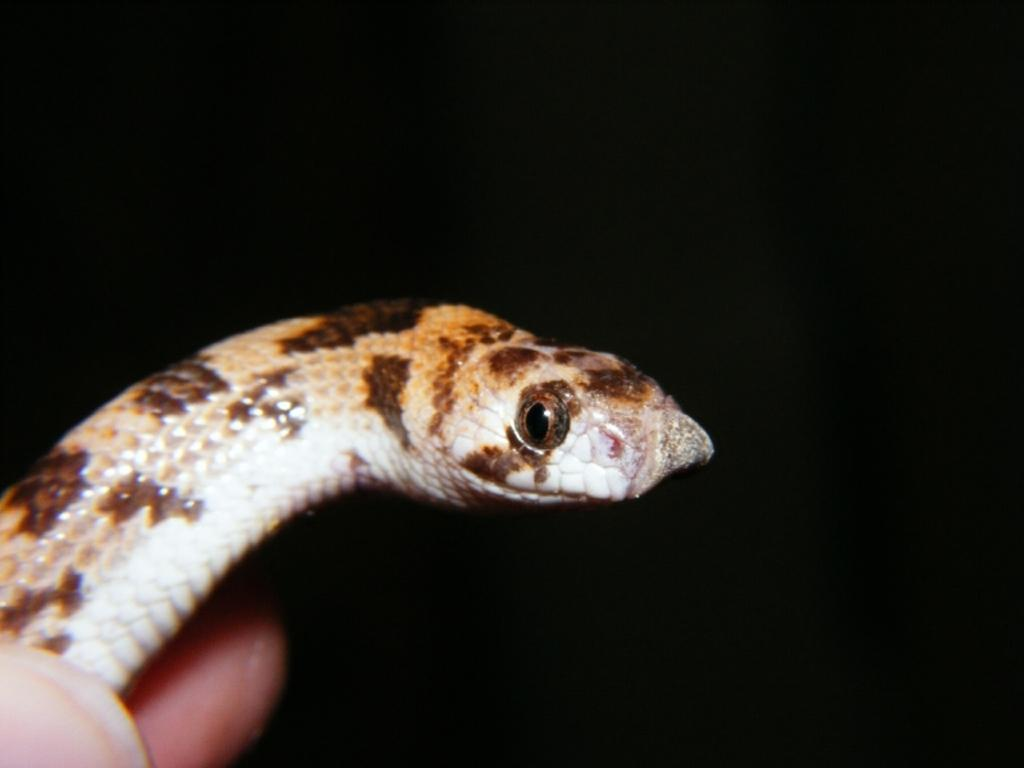What type of animal is in the image? There is a snake in the image. What color is the background of the image? The background of the image is black. What type of operation is the snake performing in the image? There is no operation being performed by the snake in the image; it is simply depicted as a snake. What type of lace can be seen on the snake in the image? There is no lace present on the snake in the image; it is a regular snake. 